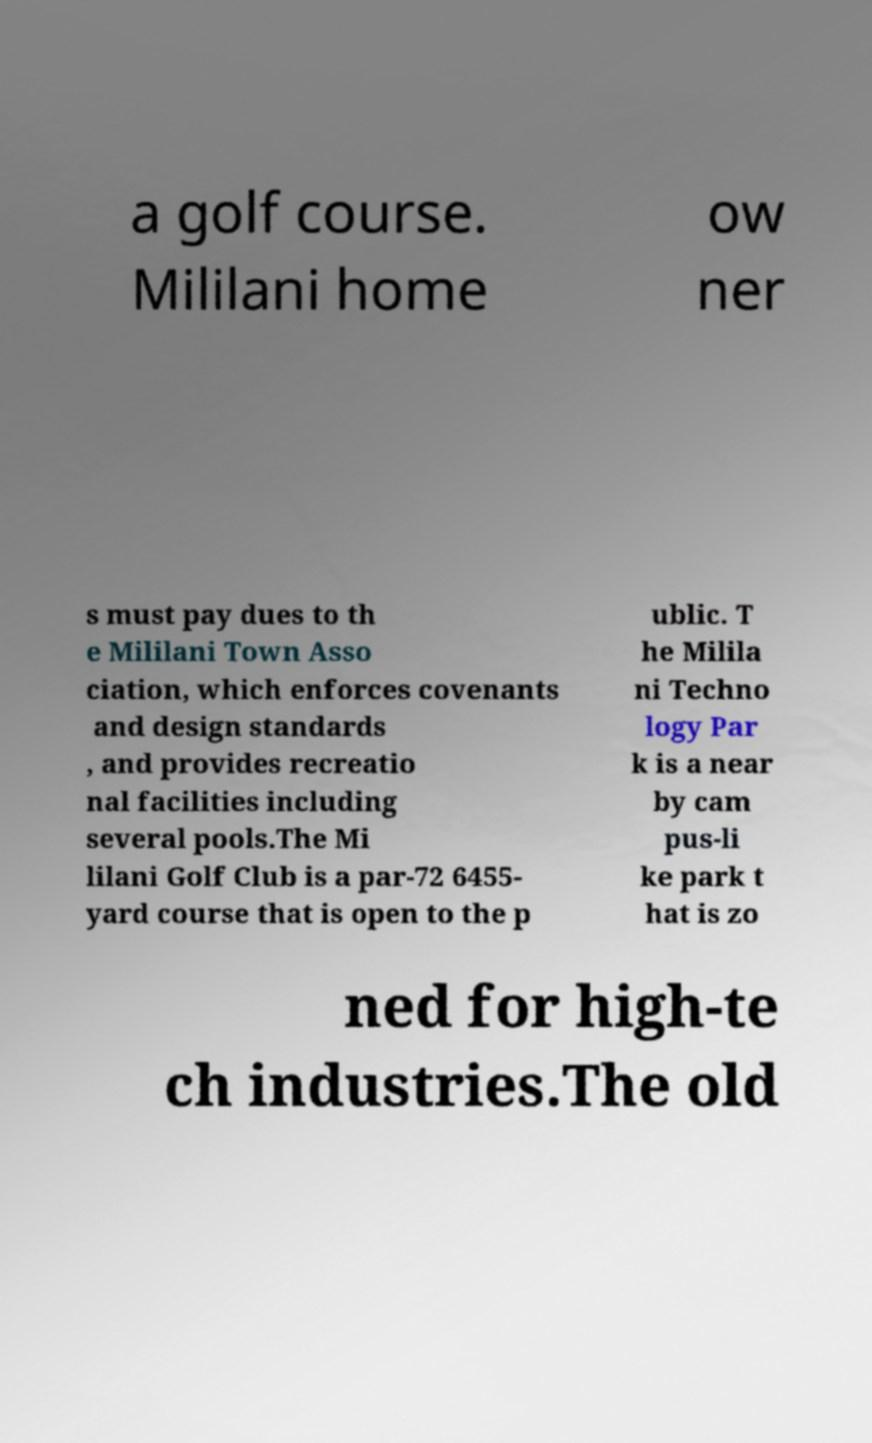For documentation purposes, I need the text within this image transcribed. Could you provide that? a golf course. Mililani home ow ner s must pay dues to th e Mililani Town Asso ciation, which enforces covenants and design standards , and provides recreatio nal facilities including several pools.The Mi lilani Golf Club is a par-72 6455- yard course that is open to the p ublic. T he Milila ni Techno logy Par k is a near by cam pus-li ke park t hat is zo ned for high-te ch industries.The old 